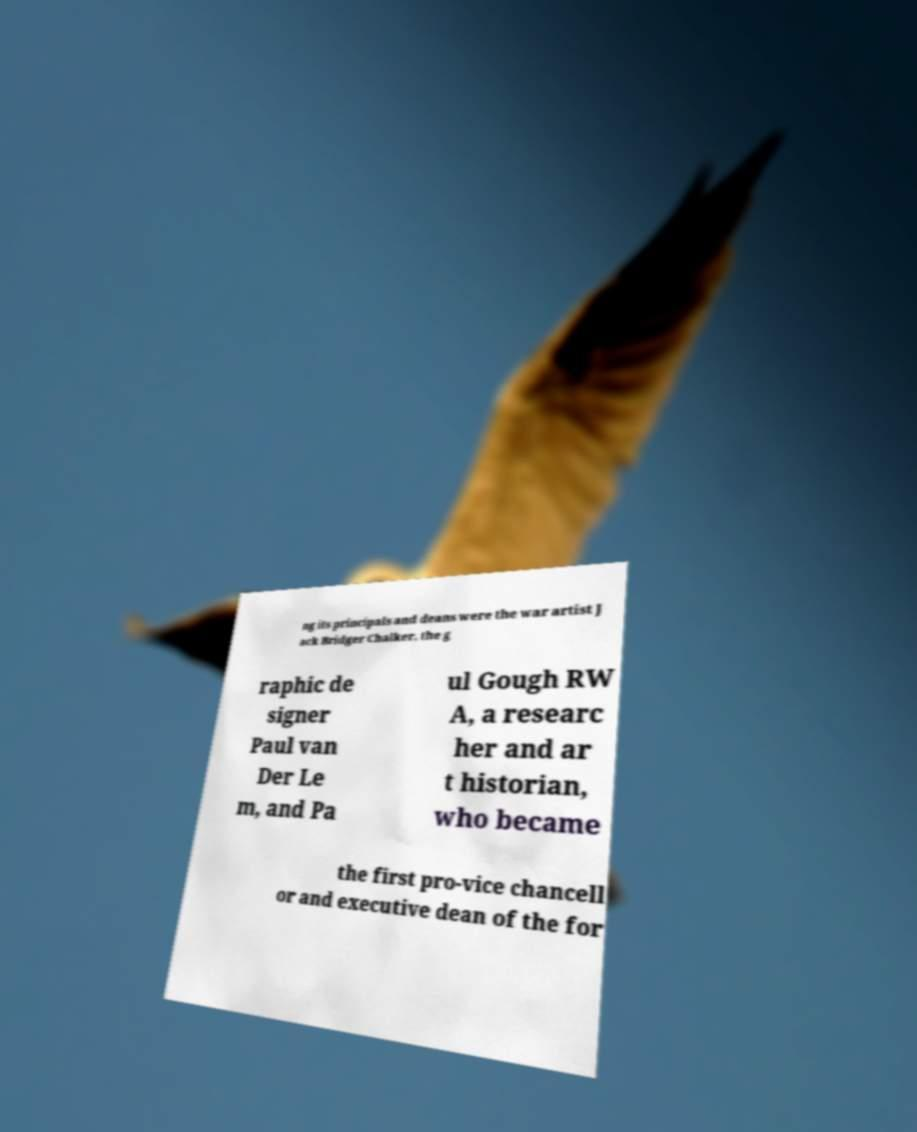What messages or text are displayed in this image? I need them in a readable, typed format. ng its principals and deans were the war artist J ack Bridger Chalker, the g raphic de signer Paul van Der Le m, and Pa ul Gough RW A, a researc her and ar t historian, who became the first pro-vice chancell or and executive dean of the for 